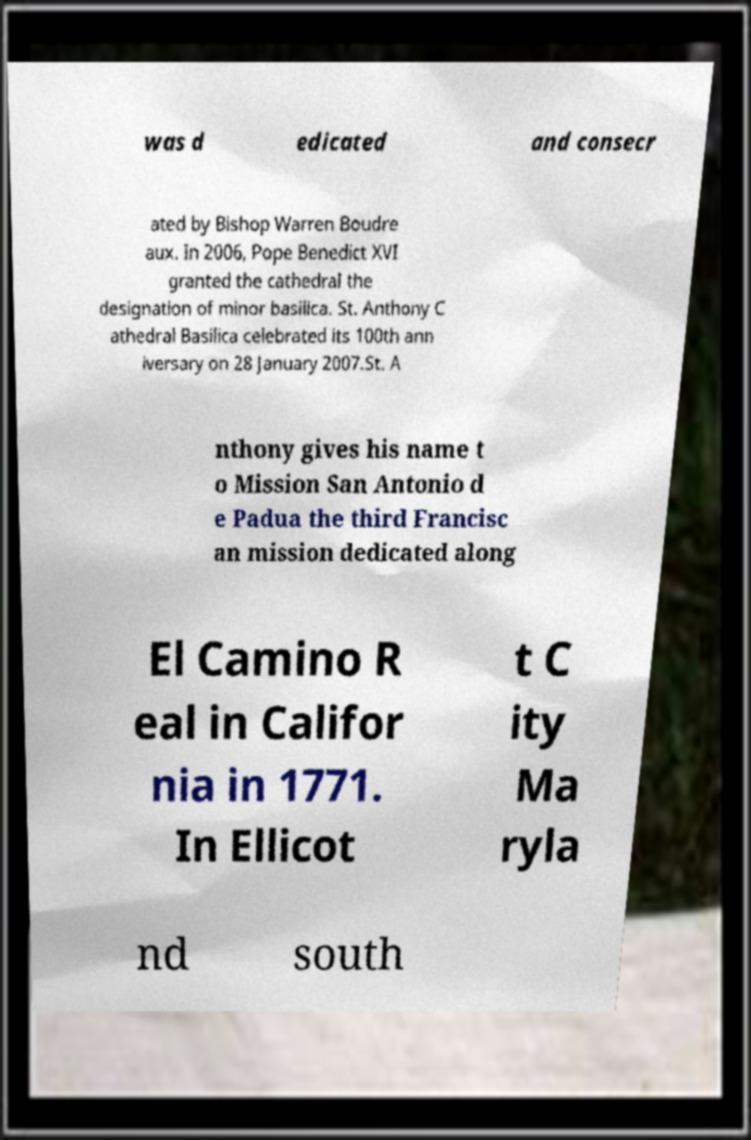Can you accurately transcribe the text from the provided image for me? was d edicated and consecr ated by Bishop Warren Boudre aux. In 2006, Pope Benedict XVI granted the cathedral the designation of minor basilica. St. Anthony C athedral Basilica celebrated its 100th ann iversary on 28 January 2007.St. A nthony gives his name t o Mission San Antonio d e Padua the third Francisc an mission dedicated along El Camino R eal in Califor nia in 1771. In Ellicot t C ity Ma ryla nd south 